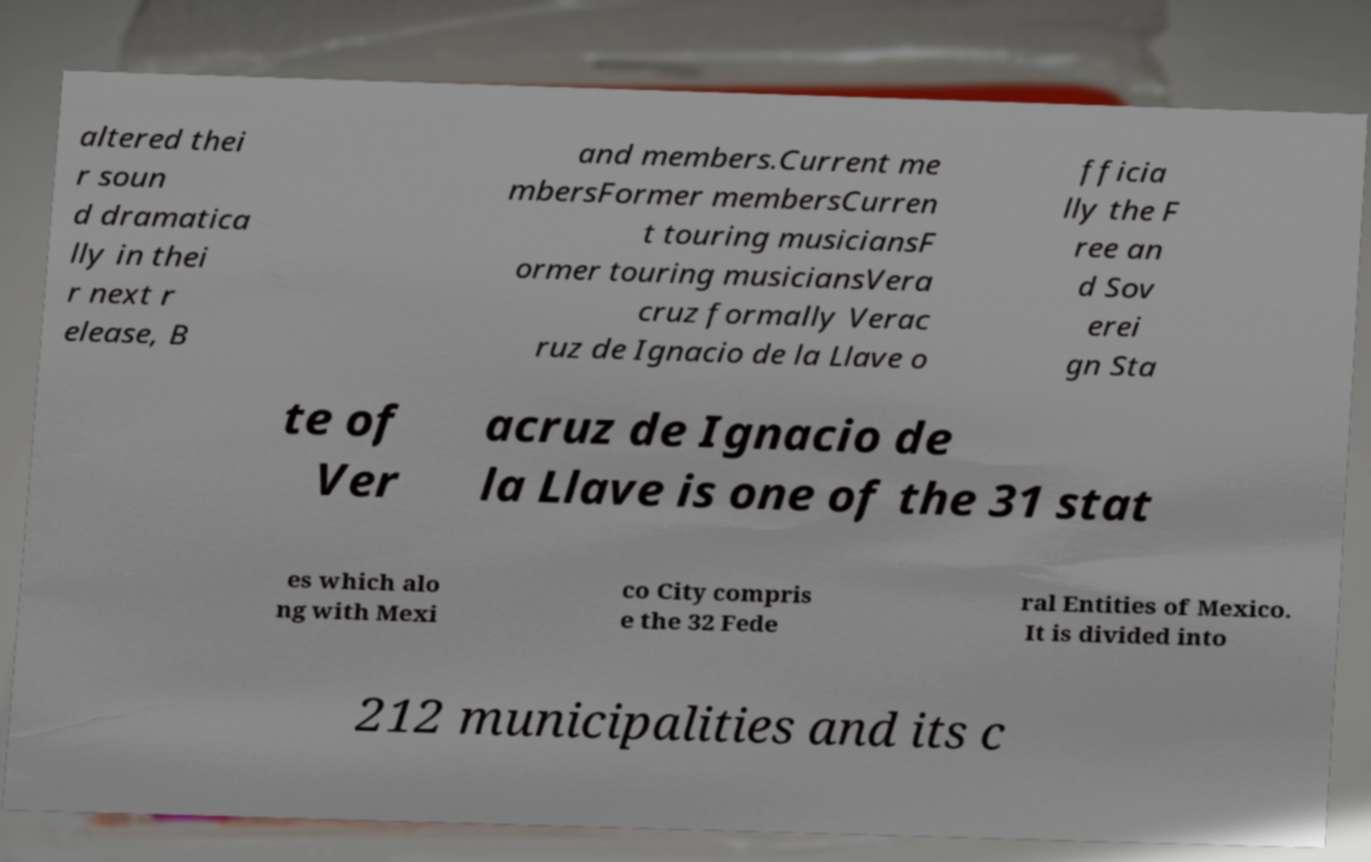What messages or text are displayed in this image? I need them in a readable, typed format. altered thei r soun d dramatica lly in thei r next r elease, B and members.Current me mbersFormer membersCurren t touring musiciansF ormer touring musiciansVera cruz formally Verac ruz de Ignacio de la Llave o fficia lly the F ree an d Sov erei gn Sta te of Ver acruz de Ignacio de la Llave is one of the 31 stat es which alo ng with Mexi co City compris e the 32 Fede ral Entities of Mexico. It is divided into 212 municipalities and its c 